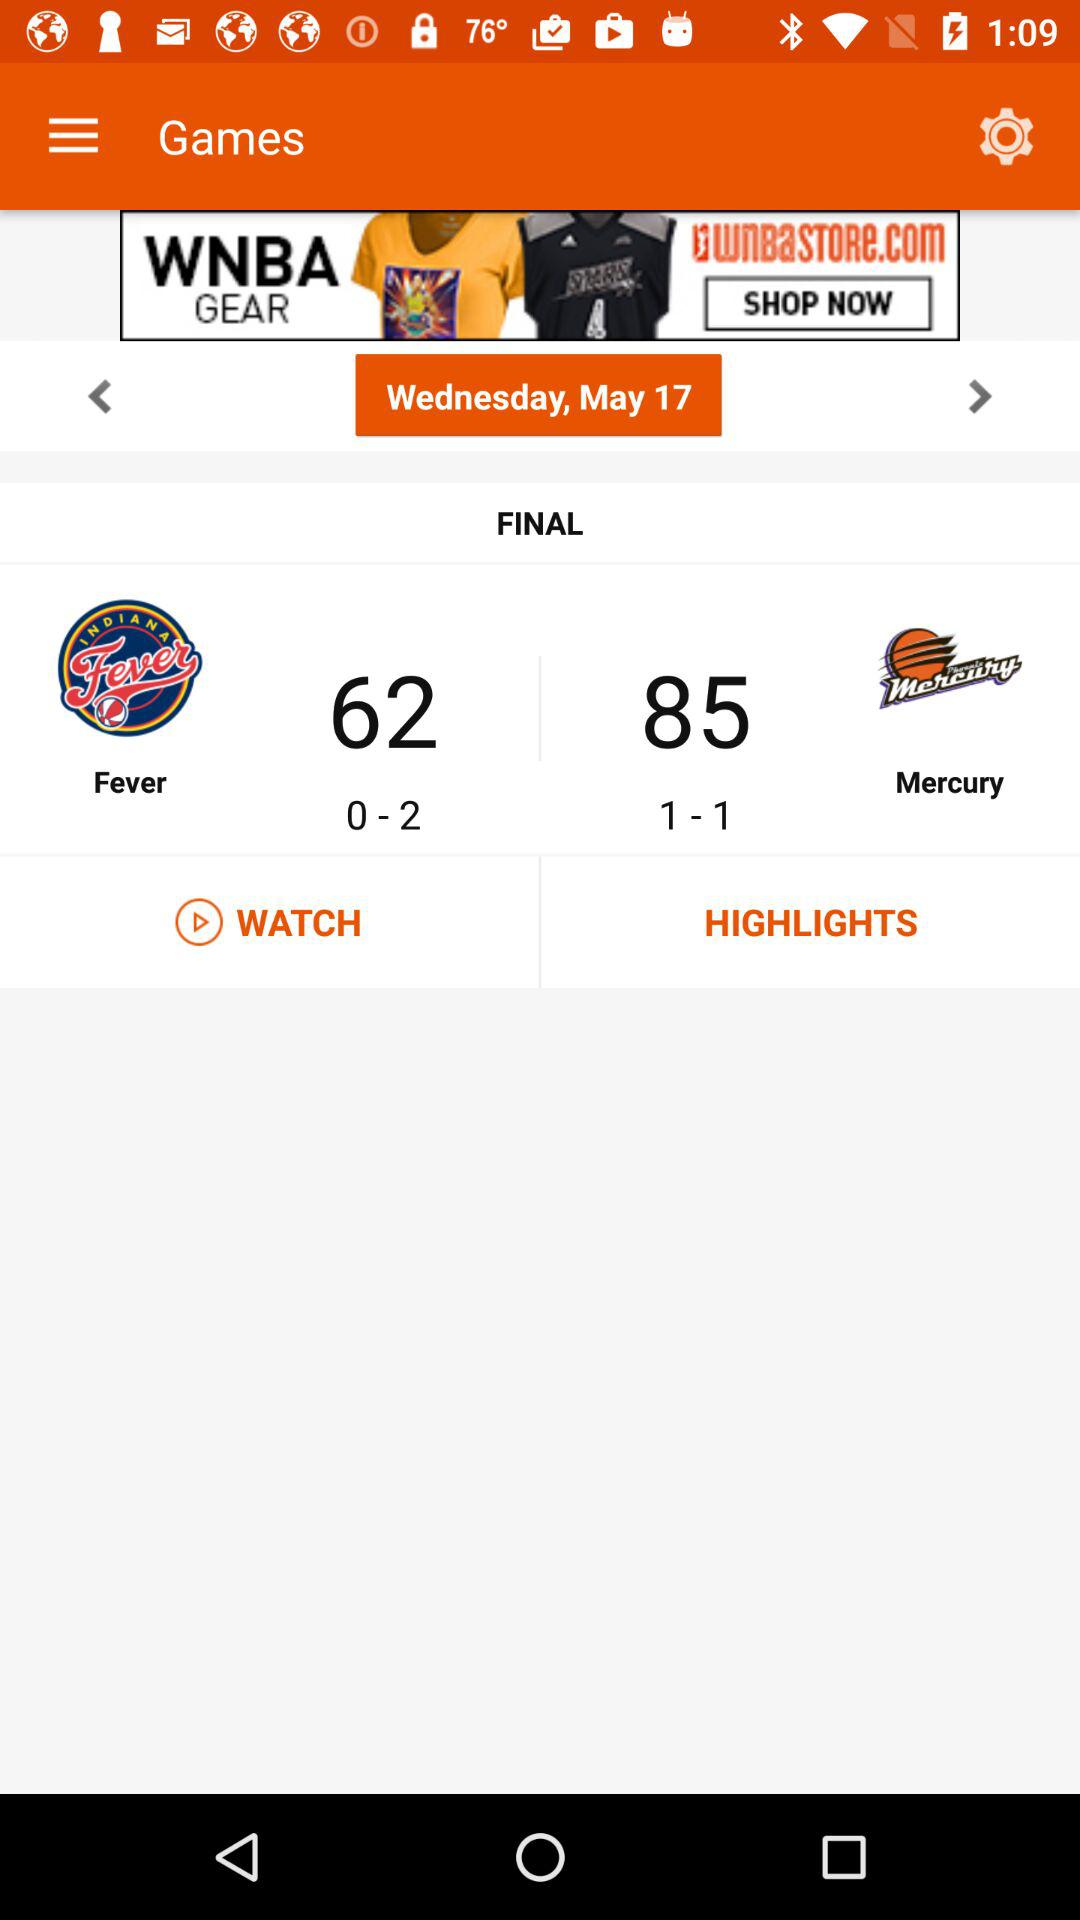What is the date? The date is Wednesday, May 17. 